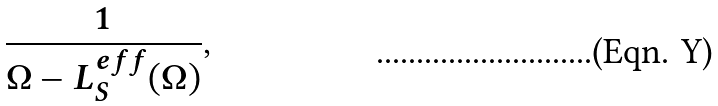Convert formula to latex. <formula><loc_0><loc_0><loc_500><loc_500>\frac { 1 } { \Omega - L _ { S } ^ { e f f } ( \Omega ) } ,</formula> 